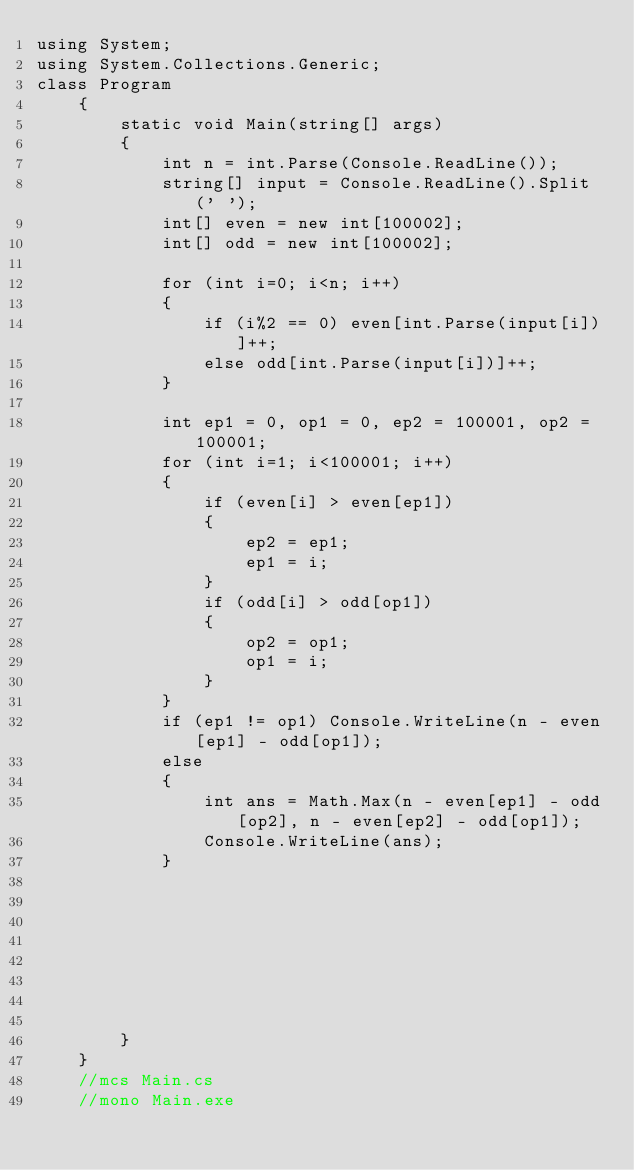Convert code to text. <code><loc_0><loc_0><loc_500><loc_500><_C#_>using System;
using System.Collections.Generic;
class Program
    {
        static void Main(string[] args)
        {
            int n = int.Parse(Console.ReadLine());
            string[] input = Console.ReadLine().Split(' ');
            int[] even = new int[100002];
            int[] odd = new int[100002];

            for (int i=0; i<n; i++)
            {
                if (i%2 == 0) even[int.Parse(input[i])]++;
                else odd[int.Parse(input[i])]++;
            }

            int ep1 = 0, op1 = 0, ep2 = 100001, op2 = 100001;
            for (int i=1; i<100001; i++)
            {
                if (even[i] > even[ep1])
                {
                    ep2 = ep1;
                    ep1 = i;
                }
                if (odd[i] > odd[op1])
                {
                    op2 = op1;
                    op1 = i;
                }
            }
            if (ep1 != op1) Console.WriteLine(n - even[ep1] - odd[op1]);
            else
            {
                int ans = Math.Max(n - even[ep1] - odd[op2], n - even[ep2] - odd[op1]);
                Console.WriteLine(ans);
            }



            
            

            
            
        }
    }
    //mcs Main.cs
    //mono Main.exe</code> 